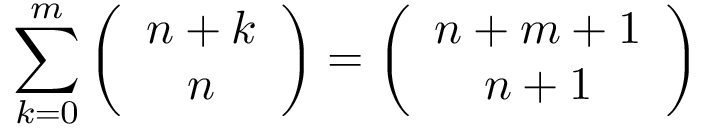Convert formula to latex. <formula><loc_0><loc_0><loc_500><loc_500>\sum _ { k = 0 } ^ { m } \left ( { \begin{array} { c } { n + k } \\ { n } \end{array} } \right ) = \left ( { \begin{array} { c } { n + m + 1 } \\ { n + 1 } \end{array} } \right )</formula> 